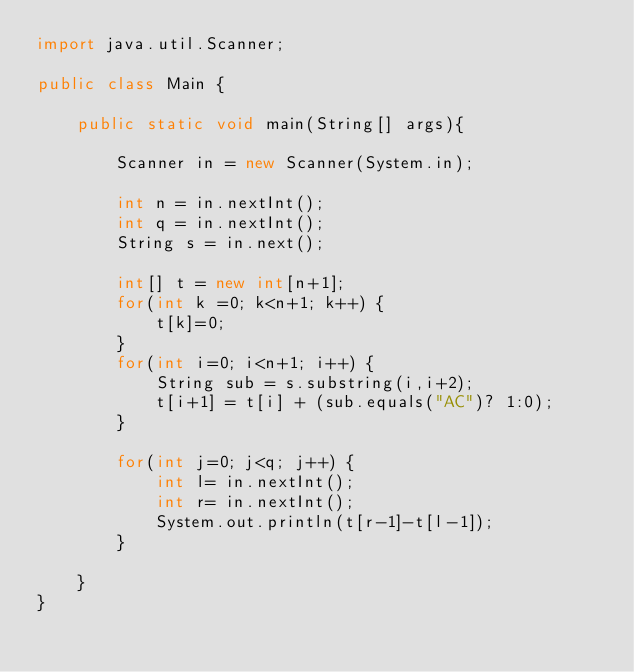<code> <loc_0><loc_0><loc_500><loc_500><_Java_>import java.util.Scanner;

public class Main {

	public static void main(String[] args){

		Scanner in = new Scanner(System.in);

		int n = in.nextInt();
		int q = in.nextInt();
		String s = in.next();

		int[] t = new int[n+1];
		for(int k =0; k<n+1; k++) {
			t[k]=0;
		}
		for(int i=0; i<n+1; i++) {
			String sub = s.substring(i,i+2);
			t[i+1] = t[i] + (sub.equals("AC")? 1:0);
		}

		for(int j=0; j<q; j++) {
			int l= in.nextInt();
			int r= in.nextInt();
			System.out.println(t[r-1]-t[l-1]);
		}

	}
}
</code> 